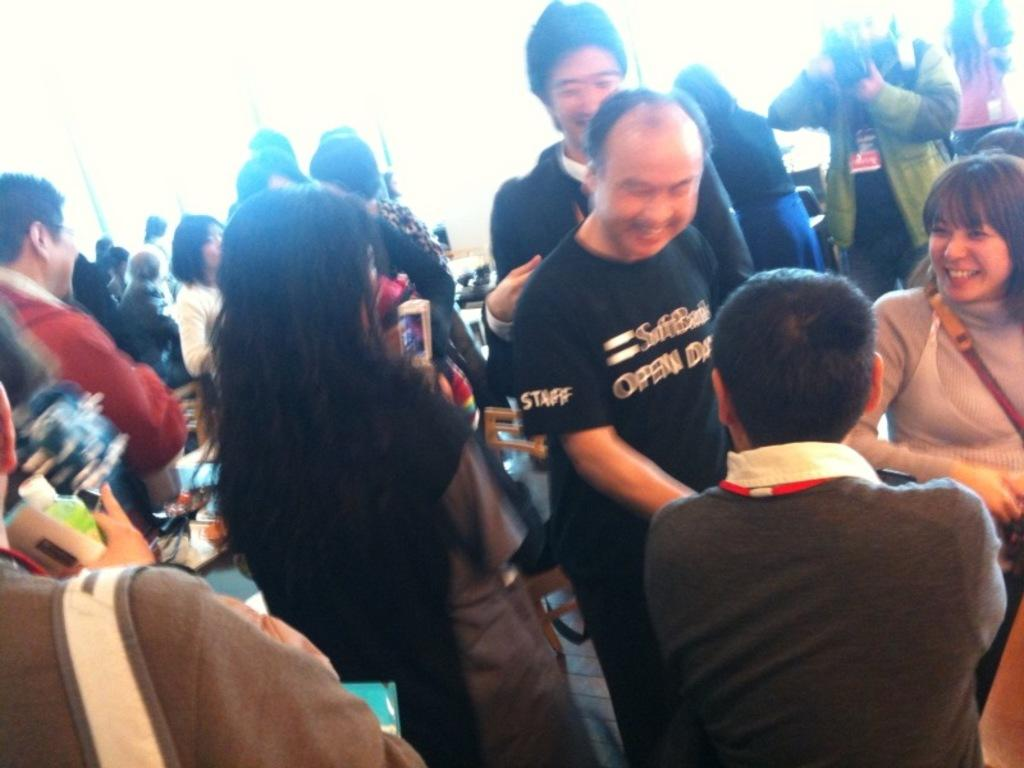How many people are visible in the image? There are multiple people in the image. Can you describe the people in the front of the image? Two men and a woman are in the front of the image. What expression do the two men and the woman have? The two men and the woman are smiling}. What is the color of the background in the image? The background of the image is entirely white. What type of map can be seen in the image? There is no map present in the image. What season is depicted in the image? The image does not depict a specific season, as the background is entirely white. What type of industry is shown in the image? There is no industry depicted in the image. 